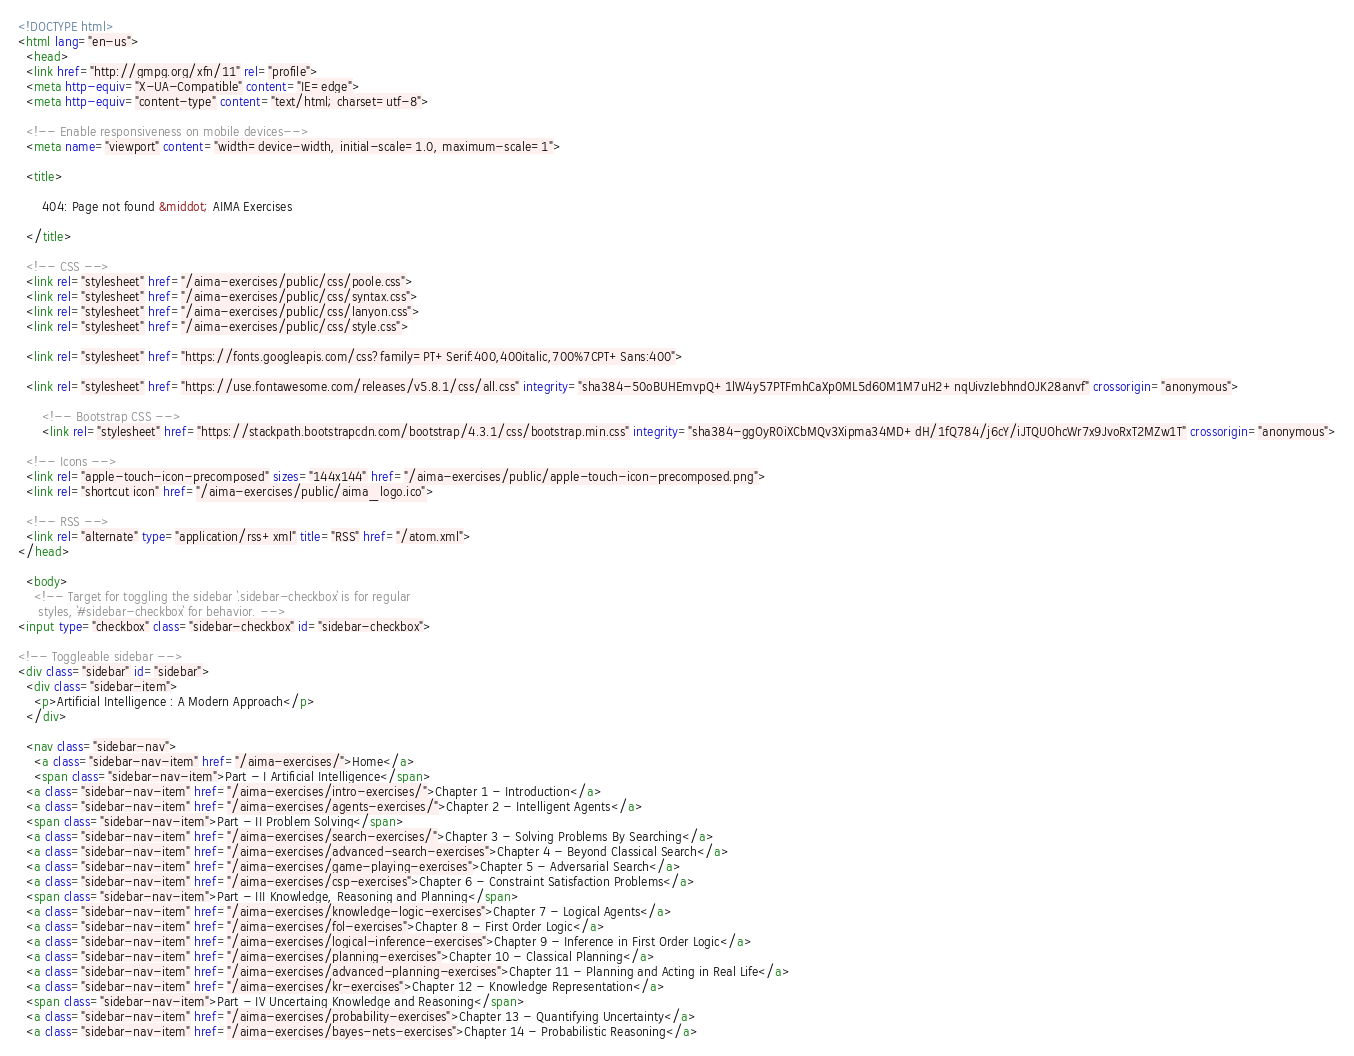Convert code to text. <code><loc_0><loc_0><loc_500><loc_500><_HTML_><!DOCTYPE html>
<html lang="en-us">
  <head>
  <link href="http://gmpg.org/xfn/11" rel="profile">
  <meta http-equiv="X-UA-Compatible" content="IE=edge">
  <meta http-equiv="content-type" content="text/html; charset=utf-8">

  <!-- Enable responsiveness on mobile devices-->
  <meta name="viewport" content="width=device-width, initial-scale=1.0, maximum-scale=1">

  <title>
    
      404: Page not found &middot; AIMA Exercises 
    
  </title>

  <!-- CSS -->
  <link rel="stylesheet" href="/aima-exercises/public/css/poole.css">
  <link rel="stylesheet" href="/aima-exercises/public/css/syntax.css">
  <link rel="stylesheet" href="/aima-exercises/public/css/lanyon.css">
  <link rel="stylesheet" href="/aima-exercises/public/css/style.css">
  
  <link rel="stylesheet" href="https://fonts.googleapis.com/css?family=PT+Serif:400,400italic,700%7CPT+Sans:400">

  <link rel="stylesheet" href="https://use.fontawesome.com/releases/v5.8.1/css/all.css" integrity="sha384-50oBUHEmvpQ+1lW4y57PTFmhCaXp0ML5d60M1M7uH2+nqUivzIebhndOJK28anvf" crossorigin="anonymous">

      <!-- Bootstrap CSS -->
      <link rel="stylesheet" href="https://stackpath.bootstrapcdn.com/bootstrap/4.3.1/css/bootstrap.min.css" integrity="sha384-ggOyR0iXCbMQv3Xipma34MD+dH/1fQ784/j6cY/iJTQUOhcWr7x9JvoRxT2MZw1T" crossorigin="anonymous">

  <!-- Icons -->
  <link rel="apple-touch-icon-precomposed" sizes="144x144" href="/aima-exercises/public/apple-touch-icon-precomposed.png">
  <link rel="shortcut icon" href="/aima-exercises/public/aima_logo.ico">

  <!-- RSS -->
  <link rel="alternate" type="application/rss+xml" title="RSS" href="/atom.xml">
</head>

  <body>
    <!-- Target for toggling the sidebar `.sidebar-checkbox` is for regular
     styles, `#sidebar-checkbox` for behavior. -->
<input type="checkbox" class="sidebar-checkbox" id="sidebar-checkbox">

<!-- Toggleable sidebar -->
<div class="sidebar" id="sidebar">
  <div class="sidebar-item">
    <p>Artificial Intelligence : A Modern Approach</p>
  </div>

  <nav class="sidebar-nav">
    <a class="sidebar-nav-item" href="/aima-exercises/">Home</a>
    <span class="sidebar-nav-item">Part - I Artificial Intelligence</span>
  <a class="sidebar-nav-item" href="/aima-exercises/intro-exercises/">Chapter 1 - Introduction</a>
  <a class="sidebar-nav-item" href="/aima-exercises/agents-exercises/">Chapter 2 - Intelligent Agents</a>
  <span class="sidebar-nav-item">Part - II Problem Solving</span>
  <a class="sidebar-nav-item" href="/aima-exercises/search-exercises/">Chapter 3 - Solving Problems By Searching</a>
  <a class="sidebar-nav-item" href="/aima-exercises/advanced-search-exercises">Chapter 4 - Beyond Classical Search</a>
  <a class="sidebar-nav-item" href="/aima-exercises/game-playing-exercises">Chapter 5 - Adversarial Search</a>
  <a class="sidebar-nav-item" href="/aima-exercises/csp-exercises">Chapter 6 - Constraint Satisfaction Problems</a>
  <span class="sidebar-nav-item">Part - III Knowledge, Reasoning and Planning</span>
  <a class="sidebar-nav-item" href="/aima-exercises/knowledge-logic-exercises">Chapter 7 - Logical Agents</a>
  <a class="sidebar-nav-item" href="/aima-exercises/fol-exercises">Chapter 8 - First Order Logic</a>
  <a class="sidebar-nav-item" href="/aima-exercises/logical-inference-exercises">Chapter 9 - Inference in First Order Logic</a>
  <a class="sidebar-nav-item" href="/aima-exercises/planning-exercises">Chapter 10 - Classical Planning</a>
  <a class="sidebar-nav-item" href="/aima-exercises/advanced-planning-exercises">Chapter 11 - Planning and Acting in Real Life</a>
  <a class="sidebar-nav-item" href="/aima-exercises/kr-exercises">Chapter 12 - Knowledge Representation</a>
  <span class="sidebar-nav-item">Part - IV Uncertaing Knowledge and Reasoning</span>
  <a class="sidebar-nav-item" href="/aima-exercises/probability-exercises">Chapter 13 - Quantifying Uncertainty</a>
  <a class="sidebar-nav-item" href="/aima-exercises/bayes-nets-exercises">Chapter 14 - Probabilistic Reasoning</a></code> 